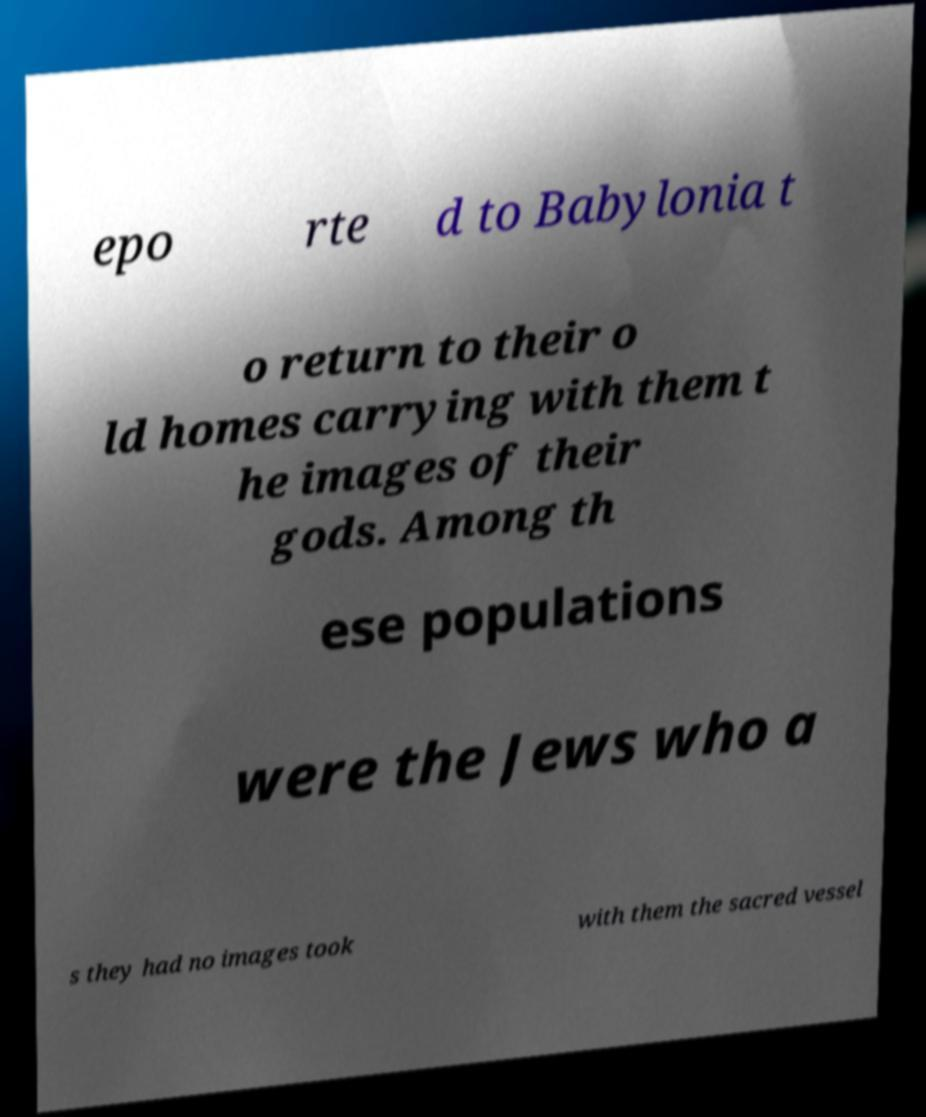There's text embedded in this image that I need extracted. Can you transcribe it verbatim? epo rte d to Babylonia t o return to their o ld homes carrying with them t he images of their gods. Among th ese populations were the Jews who a s they had no images took with them the sacred vessel 